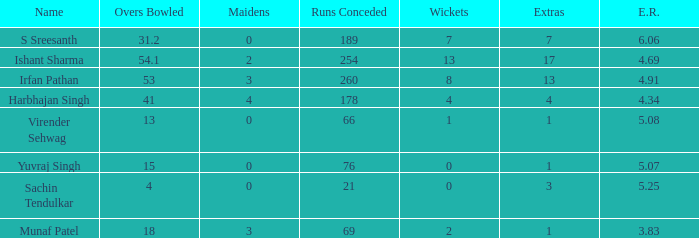What is the overall count of wickets taken by yuvraj singh? 1.0. 